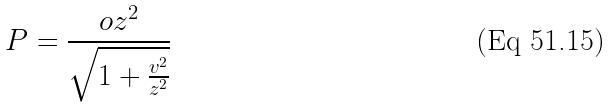<formula> <loc_0><loc_0><loc_500><loc_500>P = \frac { o z ^ { 2 } } { \sqrt { 1 + \frac { v ^ { 2 } } { z ^ { 2 } } } }</formula> 